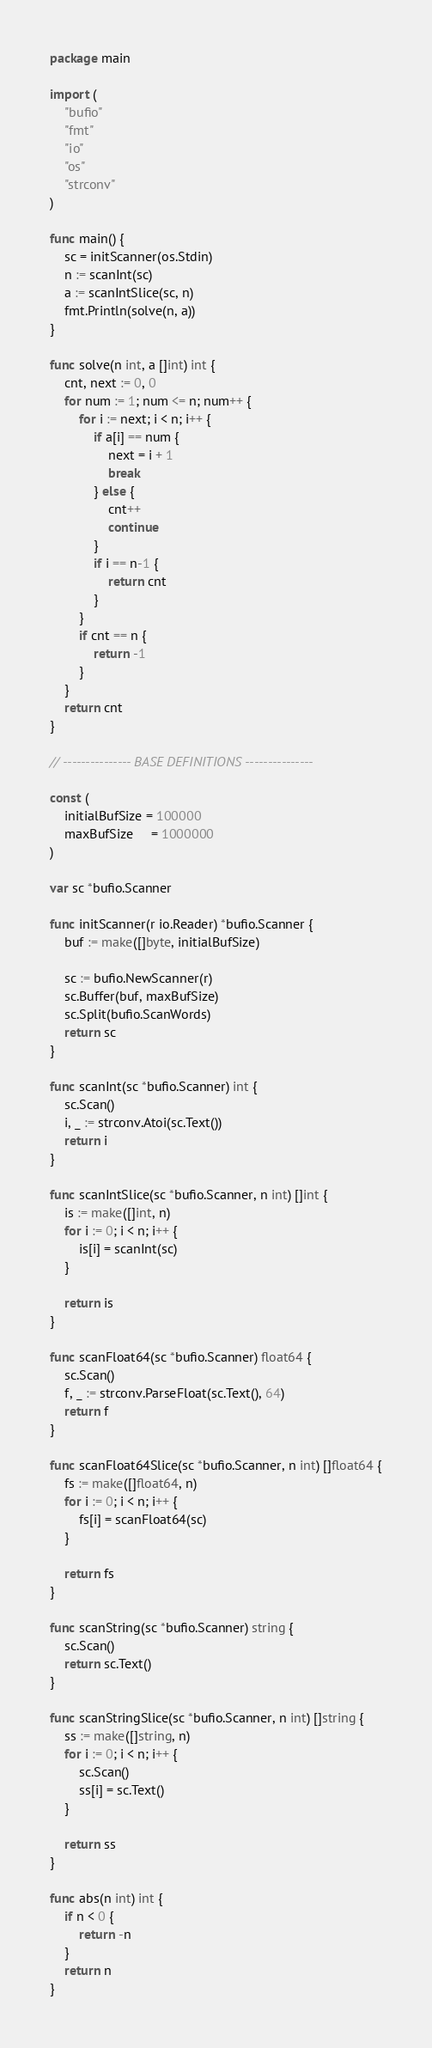Convert code to text. <code><loc_0><loc_0><loc_500><loc_500><_Go_>package main

import (
	"bufio"
	"fmt"
	"io"
	"os"
	"strconv"
)

func main() {
	sc = initScanner(os.Stdin)
	n := scanInt(sc)
	a := scanIntSlice(sc, n)
	fmt.Println(solve(n, a))
}

func solve(n int, a []int) int {
	cnt, next := 0, 0
	for num := 1; num <= n; num++ {
		for i := next; i < n; i++ {
			if a[i] == num {
				next = i + 1
				break
			} else {
				cnt++
				continue
			}
			if i == n-1 {
				return cnt
			}
		}
		if cnt == n {
			return -1
		}
	}
	return cnt
}

// --------------- BASE DEFINITIONS ---------------

const (
	initialBufSize = 100000
	maxBufSize     = 1000000
)

var sc *bufio.Scanner

func initScanner(r io.Reader) *bufio.Scanner {
	buf := make([]byte, initialBufSize)

	sc := bufio.NewScanner(r)
	sc.Buffer(buf, maxBufSize)
	sc.Split(bufio.ScanWords)
	return sc
}

func scanInt(sc *bufio.Scanner) int {
	sc.Scan()
	i, _ := strconv.Atoi(sc.Text())
	return i
}

func scanIntSlice(sc *bufio.Scanner, n int) []int {
	is := make([]int, n)
	for i := 0; i < n; i++ {
		is[i] = scanInt(sc)
	}

	return is
}

func scanFloat64(sc *bufio.Scanner) float64 {
	sc.Scan()
	f, _ := strconv.ParseFloat(sc.Text(), 64)
	return f
}

func scanFloat64Slice(sc *bufio.Scanner, n int) []float64 {
	fs := make([]float64, n)
	for i := 0; i < n; i++ {
		fs[i] = scanFloat64(sc)
	}

	return fs
}

func scanString(sc *bufio.Scanner) string {
	sc.Scan()
	return sc.Text()
}

func scanStringSlice(sc *bufio.Scanner, n int) []string {
	ss := make([]string, n)
	for i := 0; i < n; i++ {
		sc.Scan()
		ss[i] = sc.Text()
	}

	return ss
}

func abs(n int) int {
	if n < 0 {
		return -n
	}
	return n
}
</code> 